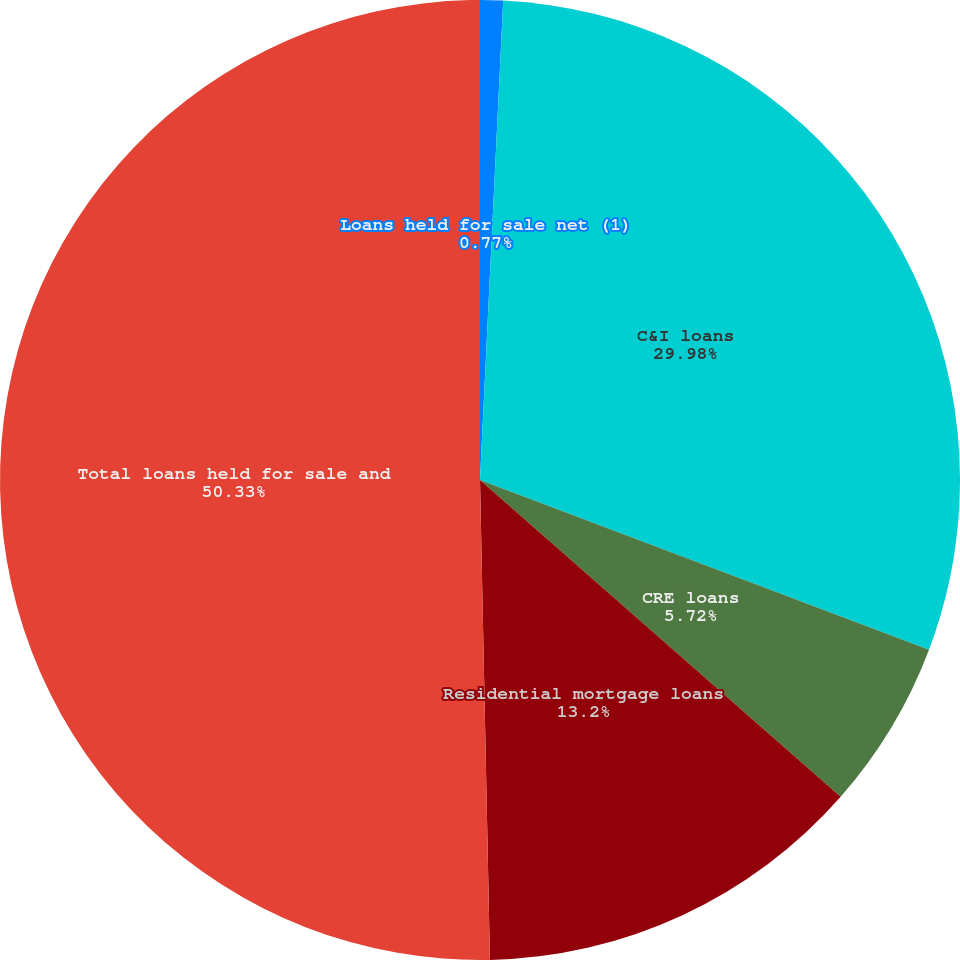<chart> <loc_0><loc_0><loc_500><loc_500><pie_chart><fcel>Loans held for sale net (1)<fcel>C&I loans<fcel>CRE loans<fcel>Residential mortgage loans<fcel>Total loans held for sale and<nl><fcel>0.77%<fcel>29.98%<fcel>5.72%<fcel>13.2%<fcel>50.33%<nl></chart> 